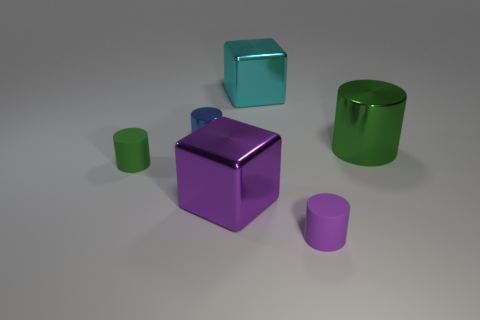There is a small rubber object that is the same color as the large cylinder; what shape is it?
Offer a terse response. Cylinder. Is there another big thing that has the same shape as the large cyan shiny object?
Your response must be concise. Yes. There is a metallic cube that is in front of the small green rubber thing; is it the same size as the green thing in front of the green metallic cylinder?
Ensure brevity in your answer.  No. There is a large thing that is on the left side of the object that is behind the blue metal cylinder; what shape is it?
Ensure brevity in your answer.  Cube. What number of purple metallic objects have the same size as the green metal cylinder?
Offer a very short reply. 1. Is there a large yellow cube?
Provide a succinct answer. No. Is there anything else that is the same color as the small shiny cylinder?
Offer a terse response. No. There is a small thing that is made of the same material as the small green cylinder; what shape is it?
Provide a succinct answer. Cylinder. There is a large thing in front of the object to the right of the cylinder in front of the green rubber thing; what color is it?
Ensure brevity in your answer.  Purple. Are there an equal number of tiny rubber things in front of the tiny purple matte thing and red metallic things?
Give a very brief answer. Yes. 